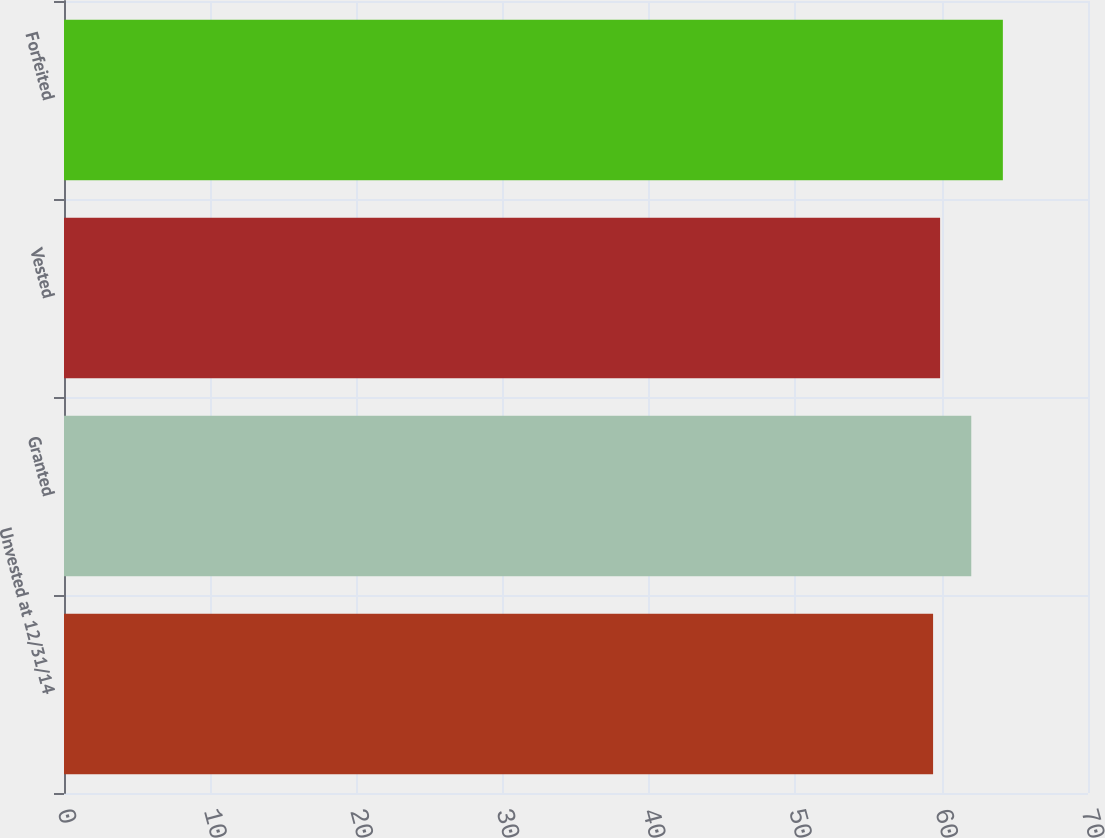Convert chart. <chart><loc_0><loc_0><loc_500><loc_500><bar_chart><fcel>Unvested at 12/31/14<fcel>Granted<fcel>Vested<fcel>Forfeited<nl><fcel>59.41<fcel>62.02<fcel>59.89<fcel>64.18<nl></chart> 